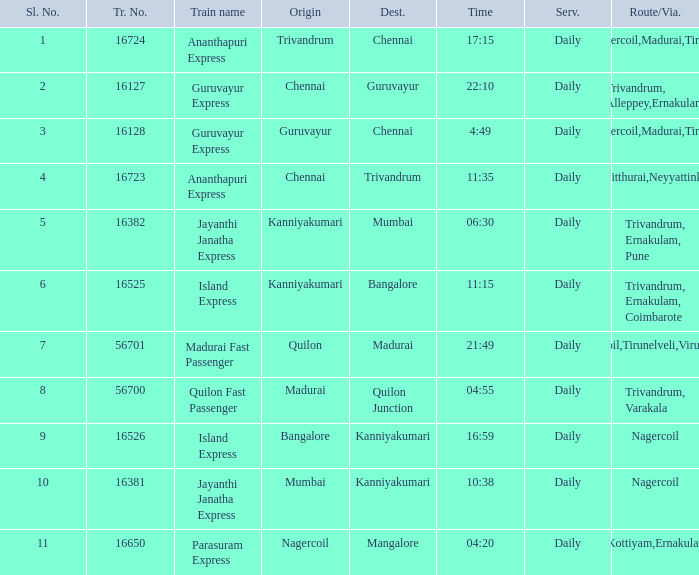What is the route/via when the train name is Parasuram Express? Trivandrum,Kottiyam,Ernakulam,Kozhikode. 